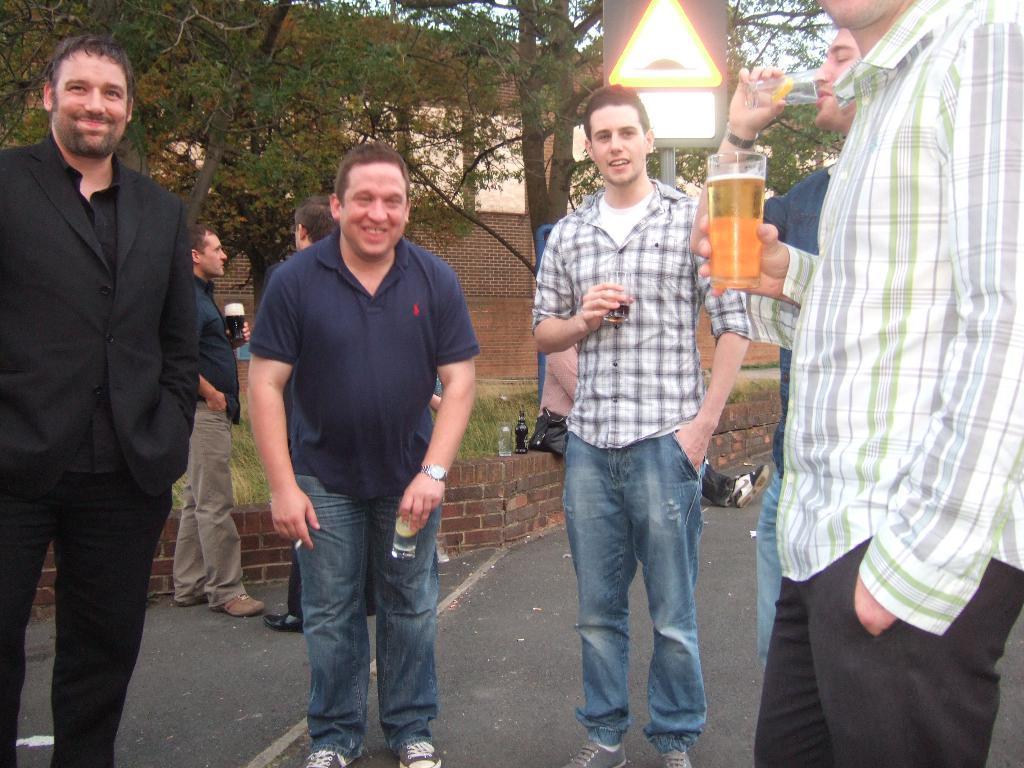Please provide a concise description of this image. In this image we can see five men are standing. One man is wearing shirt and holding glass in his hand. Behind them two more men are standing and trees are present. 